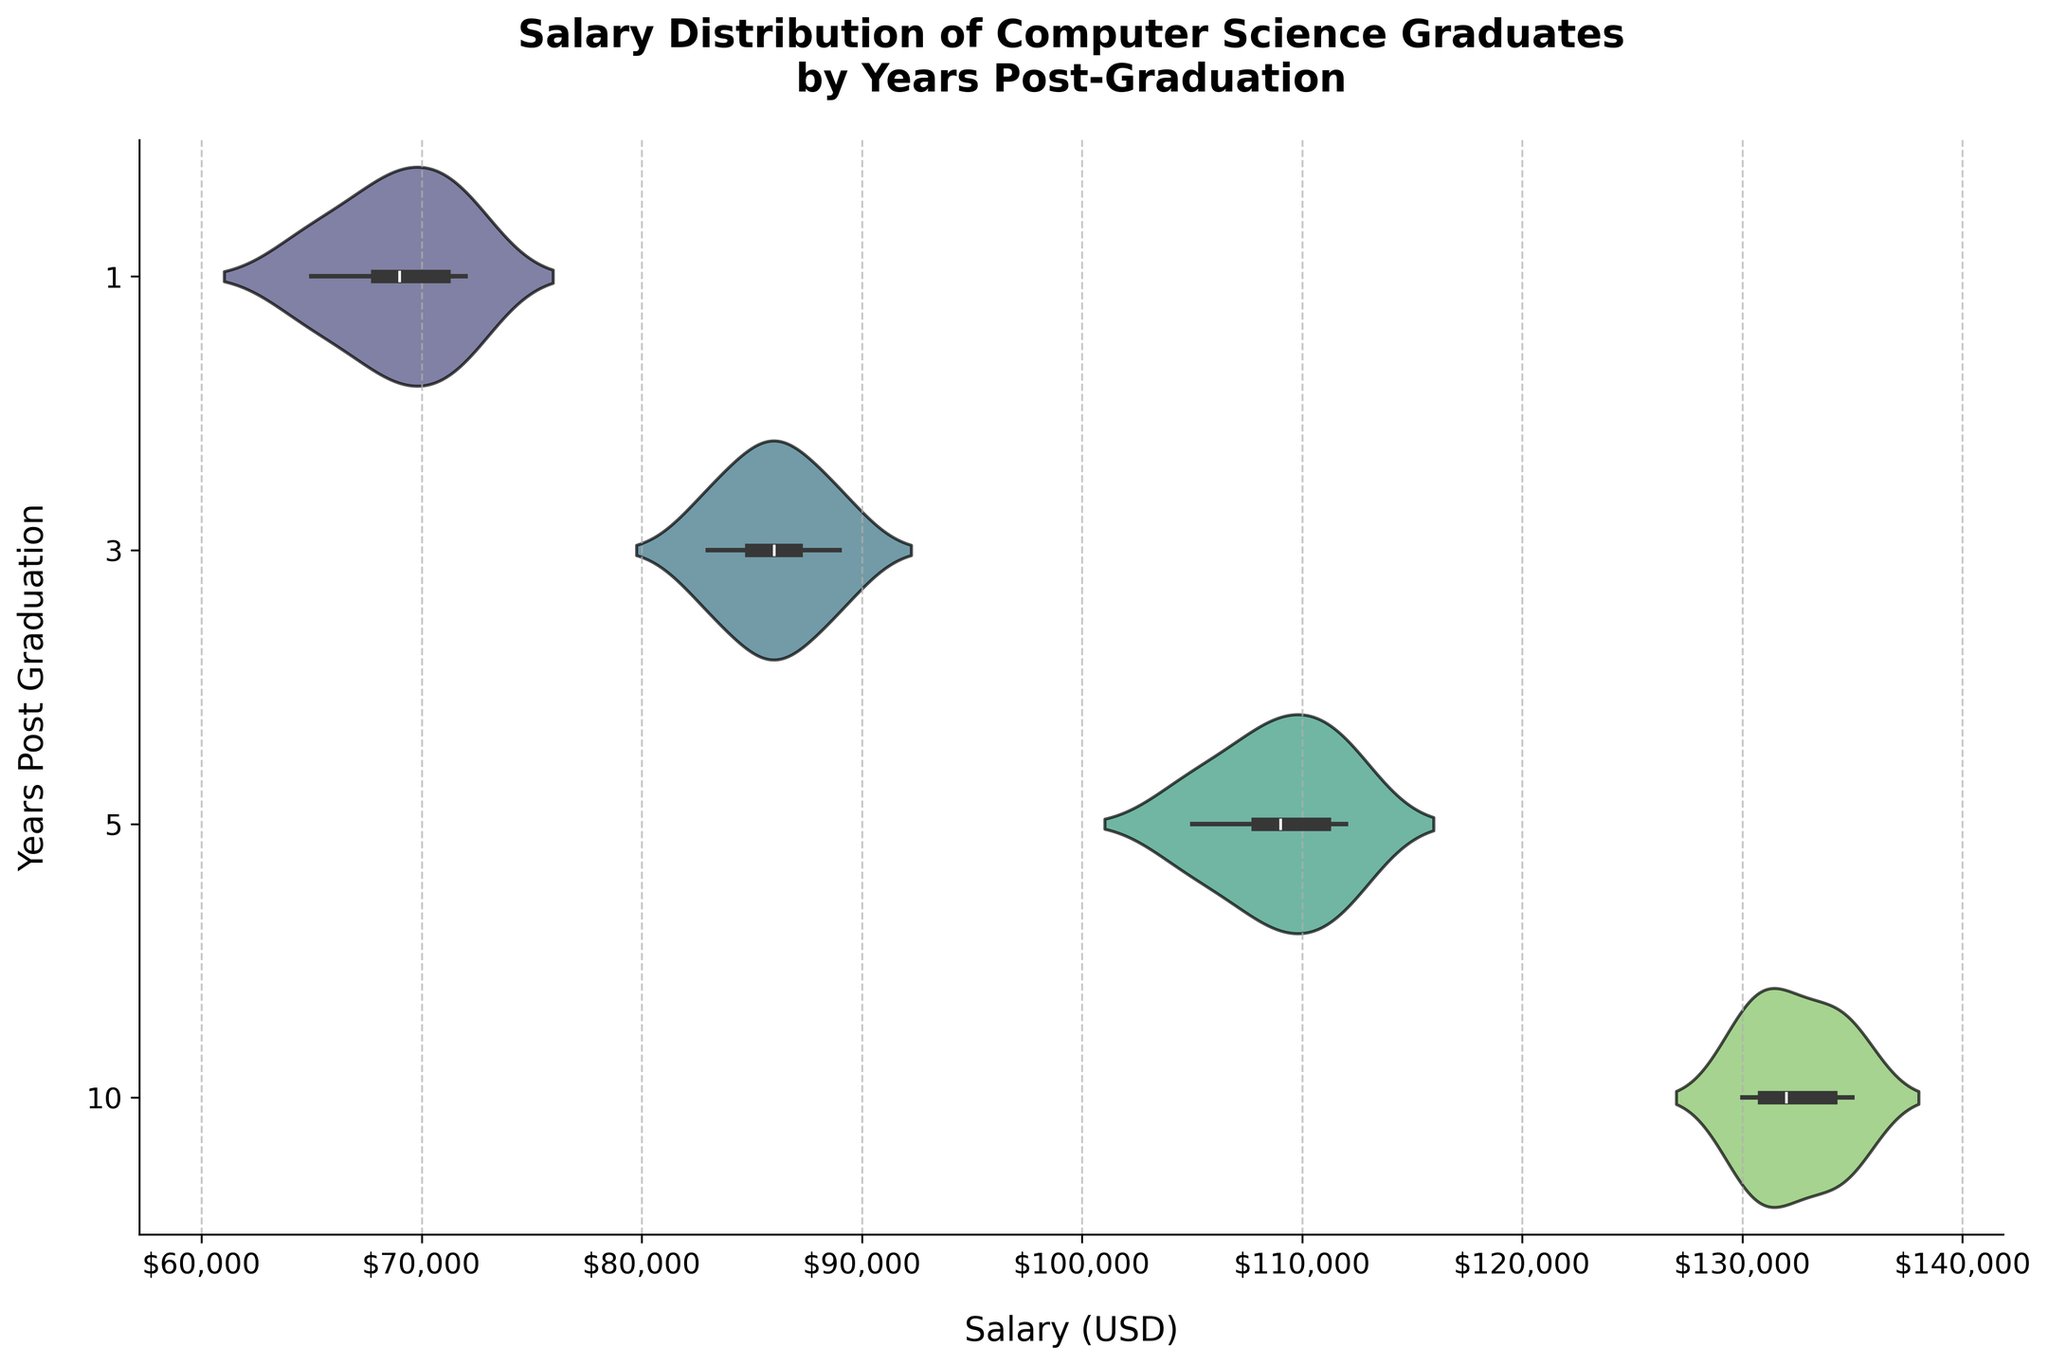What is the title of the figure? The title is found at the top of the figure. It summarizes the main idea of the plot, stating what is being visualized.
Answer: Salary Distribution of Computer Science Graduates by Years Post-Graduation How many years post-graduation are displayed in the figure? The y-axis shows the different points in time after graduation. Count the number of unique labels along this axis.
Answer: 4 Which year post-graduation has the highest median salary according to the violin plot? To find the year with the highest median salary, look at the position of the box (representing the median) within each violin. Identify the one with the box located at the highest salary value.
Answer: 10 years Which year post-graduation shows the widest range of salary distribution? The widest violin plot indicates the year with the greatest range in salaries. Look for the violin with the most spread from top to bottom.
Answer: 3 years What is the approximate median salary for graduates 1 year post-graduation? The median is represented by the white dot within the inner box of the violin plot. Locate this dot within the 1-year violin and estimate its salary value along the x-axis.
Answer: Around $69,000 How does the salary distribution for 5 years post-graduation compare to 3 years post-graduation? Compare the shapes and spreads of the violin plots for 3 years and 5 years. Note both the median positions and the overall spread of salaries.
Answer: The 5-year salary distribution has a higher median and a more condensed spread compared to the 3-year distribution Which year post-graduation has the narrowest interquartile range (IQR) of salaries? The inner box in each violin plot represents the IQR. Identify the violin with the smallest height of this box.
Answer: 1 year What trend can be observed in median salaries as years post-graduation increase? Observe the position of the medians (white dots) in each violin plot as the years post-graduation increase. Determine if they increase, decrease, or stay the same.
Answer: Median salaries increase as years post-graduation increase What is the color palette used in the figure? The color palette can be seen in the shading of the violin plots. Interpret the specific range of colors displayed.
Answer: Viridis Is there a noticeable difference in salary distributions between 1 year and 10 years post-graduation? Compare the shapes, medians, and spreads of the violin plots for 1 year and 10 years post-graduation. Look for differences or similarities.
Answer: Yes, there's a noticeable difference; 10 years show higher median and narrower range 